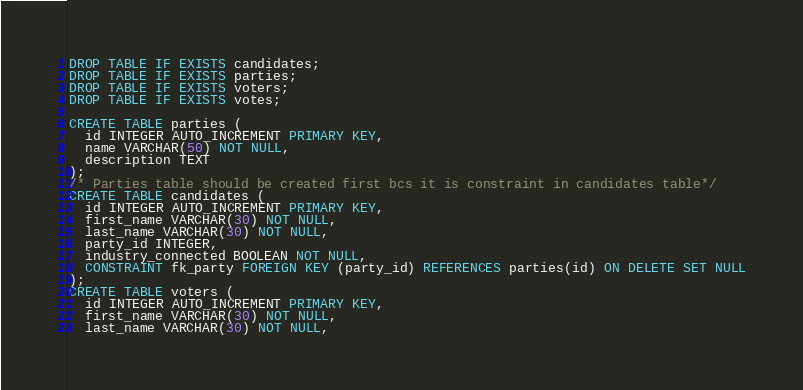Convert code to text. <code><loc_0><loc_0><loc_500><loc_500><_SQL_>DROP TABLE IF EXISTS candidates;
DROP TABLE IF EXISTS parties;
DROP TABLE IF EXISTS voters;
DROP TABLE IF EXISTS votes;

CREATE TABLE parties (
  id INTEGER AUTO_INCREMENT PRIMARY KEY,
  name VARCHAR(50) NOT NULL,
  description TEXT
);
/* Parties table should be created first bcs it is constraint in candidates table*/
CREATE TABLE candidates (
  id INTEGER AUTO_INCREMENT PRIMARY KEY,
  first_name VARCHAR(30) NOT NULL,
  last_name VARCHAR(30) NOT NULL,
  party_id INTEGER,
  industry_connected BOOLEAN NOT NULL,
  CONSTRAINT fk_party FOREIGN KEY (party_id) REFERENCES parties(id) ON DELETE SET NULL
);
CREATE TABLE voters (
  id INTEGER AUTO_INCREMENT PRIMARY KEY,
  first_name VARCHAR(30) NOT NULL,
  last_name VARCHAR(30) NOT NULL,</code> 